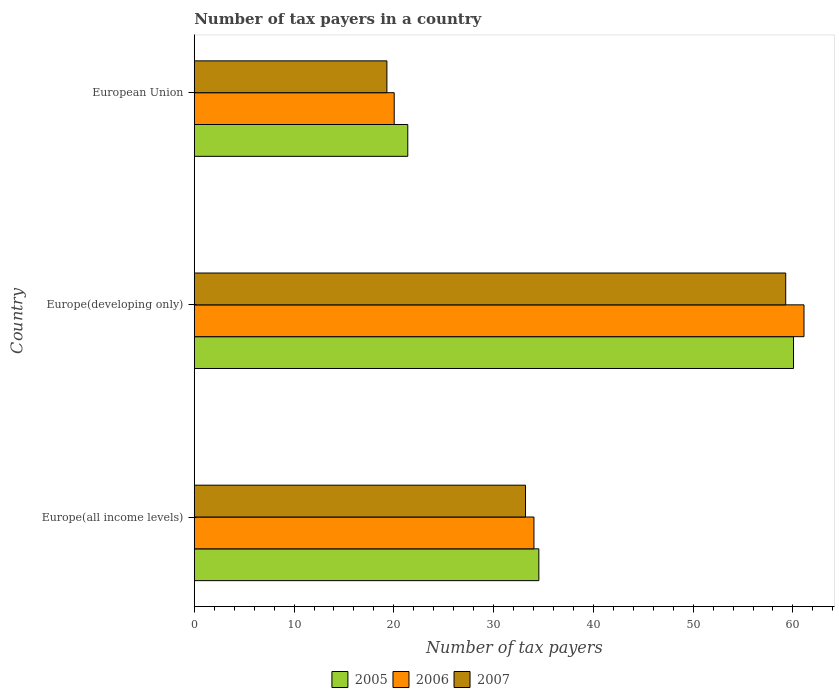How many groups of bars are there?
Ensure brevity in your answer.  3. Are the number of bars on each tick of the Y-axis equal?
Your response must be concise. Yes. What is the label of the 1st group of bars from the top?
Offer a very short reply. European Union. What is the number of tax payers in in 2006 in Europe(developing only)?
Your answer should be very brief. 61.11. Across all countries, what is the maximum number of tax payers in in 2005?
Your response must be concise. 60.06. Across all countries, what is the minimum number of tax payers in in 2005?
Your answer should be compact. 21.4. In which country was the number of tax payers in in 2005 maximum?
Offer a terse response. Europe(developing only). In which country was the number of tax payers in in 2007 minimum?
Provide a short and direct response. European Union. What is the total number of tax payers in in 2006 in the graph?
Provide a succinct answer. 115.19. What is the difference between the number of tax payers in in 2006 in Europe(all income levels) and that in European Union?
Your answer should be very brief. 14.01. What is the difference between the number of tax payers in in 2005 in Europe(developing only) and the number of tax payers in in 2006 in European Union?
Your response must be concise. 40.02. What is the average number of tax payers in in 2005 per country?
Your response must be concise. 38.66. What is the difference between the number of tax payers in in 2006 and number of tax payers in in 2007 in Europe(all income levels)?
Your answer should be compact. 0.84. In how many countries, is the number of tax payers in in 2005 greater than 8 ?
Provide a short and direct response. 3. What is the ratio of the number of tax payers in in 2006 in Europe(all income levels) to that in European Union?
Give a very brief answer. 1.7. Is the number of tax payers in in 2007 in Europe(all income levels) less than that in European Union?
Give a very brief answer. No. What is the difference between the highest and the second highest number of tax payers in in 2007?
Provide a succinct answer. 26.08. What is the difference between the highest and the lowest number of tax payers in in 2006?
Provide a short and direct response. 41.07. In how many countries, is the number of tax payers in in 2007 greater than the average number of tax payers in in 2007 taken over all countries?
Give a very brief answer. 1. Is the sum of the number of tax payers in in 2007 in Europe(all income levels) and European Union greater than the maximum number of tax payers in in 2006 across all countries?
Offer a very short reply. No. What does the 3rd bar from the bottom in European Union represents?
Ensure brevity in your answer.  2007. Is it the case that in every country, the sum of the number of tax payers in in 2007 and number of tax payers in in 2005 is greater than the number of tax payers in in 2006?
Offer a terse response. Yes. How many bars are there?
Provide a succinct answer. 9. Are all the bars in the graph horizontal?
Keep it short and to the point. Yes. What is the difference between two consecutive major ticks on the X-axis?
Your answer should be compact. 10. Does the graph contain any zero values?
Your answer should be compact. No. Does the graph contain grids?
Offer a very short reply. No. Where does the legend appear in the graph?
Ensure brevity in your answer.  Bottom center. How many legend labels are there?
Make the answer very short. 3. How are the legend labels stacked?
Ensure brevity in your answer.  Horizontal. What is the title of the graph?
Offer a very short reply. Number of tax payers in a country. Does "1984" appear as one of the legend labels in the graph?
Your answer should be compact. No. What is the label or title of the X-axis?
Your answer should be very brief. Number of tax payers. What is the label or title of the Y-axis?
Your response must be concise. Country. What is the Number of tax payers in 2005 in Europe(all income levels)?
Give a very brief answer. 34.53. What is the Number of tax payers of 2006 in Europe(all income levels)?
Give a very brief answer. 34.04. What is the Number of tax payers of 2007 in Europe(all income levels)?
Your answer should be very brief. 33.2. What is the Number of tax payers of 2005 in Europe(developing only)?
Give a very brief answer. 60.06. What is the Number of tax payers in 2006 in Europe(developing only)?
Provide a succinct answer. 61.11. What is the Number of tax payers in 2007 in Europe(developing only)?
Provide a short and direct response. 59.28. What is the Number of tax payers in 2005 in European Union?
Make the answer very short. 21.4. What is the Number of tax payers of 2006 in European Union?
Give a very brief answer. 20.04. What is the Number of tax payers in 2007 in European Union?
Make the answer very short. 19.31. Across all countries, what is the maximum Number of tax payers in 2005?
Provide a short and direct response. 60.06. Across all countries, what is the maximum Number of tax payers in 2006?
Ensure brevity in your answer.  61.11. Across all countries, what is the maximum Number of tax payers of 2007?
Keep it short and to the point. 59.28. Across all countries, what is the minimum Number of tax payers of 2005?
Your response must be concise. 21.4. Across all countries, what is the minimum Number of tax payers in 2006?
Make the answer very short. 20.04. Across all countries, what is the minimum Number of tax payers of 2007?
Provide a succinct answer. 19.31. What is the total Number of tax payers of 2005 in the graph?
Make the answer very short. 115.99. What is the total Number of tax payers in 2006 in the graph?
Your answer should be very brief. 115.19. What is the total Number of tax payers of 2007 in the graph?
Provide a succinct answer. 111.79. What is the difference between the Number of tax payers of 2005 in Europe(all income levels) and that in Europe(developing only)?
Your response must be concise. -25.52. What is the difference between the Number of tax payers in 2006 in Europe(all income levels) and that in Europe(developing only)?
Offer a very short reply. -27.07. What is the difference between the Number of tax payers in 2007 in Europe(all income levels) and that in Europe(developing only)?
Keep it short and to the point. -26.08. What is the difference between the Number of tax payers in 2005 in Europe(all income levels) and that in European Union?
Your response must be concise. 13.13. What is the difference between the Number of tax payers of 2006 in Europe(all income levels) and that in European Union?
Provide a short and direct response. 14.01. What is the difference between the Number of tax payers in 2007 in Europe(all income levels) and that in European Union?
Your response must be concise. 13.89. What is the difference between the Number of tax payers of 2005 in Europe(developing only) and that in European Union?
Provide a succinct answer. 38.66. What is the difference between the Number of tax payers of 2006 in Europe(developing only) and that in European Union?
Offer a terse response. 41.07. What is the difference between the Number of tax payers in 2007 in Europe(developing only) and that in European Union?
Your response must be concise. 39.97. What is the difference between the Number of tax payers of 2005 in Europe(all income levels) and the Number of tax payers of 2006 in Europe(developing only)?
Your answer should be compact. -26.58. What is the difference between the Number of tax payers of 2005 in Europe(all income levels) and the Number of tax payers of 2007 in Europe(developing only)?
Keep it short and to the point. -24.74. What is the difference between the Number of tax payers in 2006 in Europe(all income levels) and the Number of tax payers in 2007 in Europe(developing only)?
Ensure brevity in your answer.  -25.23. What is the difference between the Number of tax payers in 2005 in Europe(all income levels) and the Number of tax payers in 2006 in European Union?
Provide a short and direct response. 14.5. What is the difference between the Number of tax payers of 2005 in Europe(all income levels) and the Number of tax payers of 2007 in European Union?
Provide a short and direct response. 15.23. What is the difference between the Number of tax payers of 2006 in Europe(all income levels) and the Number of tax payers of 2007 in European Union?
Your answer should be very brief. 14.74. What is the difference between the Number of tax payers in 2005 in Europe(developing only) and the Number of tax payers in 2006 in European Union?
Offer a very short reply. 40.02. What is the difference between the Number of tax payers in 2005 in Europe(developing only) and the Number of tax payers in 2007 in European Union?
Offer a very short reply. 40.75. What is the difference between the Number of tax payers of 2006 in Europe(developing only) and the Number of tax payers of 2007 in European Union?
Provide a short and direct response. 41.8. What is the average Number of tax payers of 2005 per country?
Provide a short and direct response. 38.66. What is the average Number of tax payers of 2006 per country?
Keep it short and to the point. 38.4. What is the average Number of tax payers of 2007 per country?
Give a very brief answer. 37.26. What is the difference between the Number of tax payers of 2005 and Number of tax payers of 2006 in Europe(all income levels)?
Ensure brevity in your answer.  0.49. What is the difference between the Number of tax payers in 2005 and Number of tax payers in 2007 in Europe(all income levels)?
Your response must be concise. 1.33. What is the difference between the Number of tax payers of 2006 and Number of tax payers of 2007 in Europe(all income levels)?
Offer a very short reply. 0.84. What is the difference between the Number of tax payers in 2005 and Number of tax payers in 2006 in Europe(developing only)?
Make the answer very short. -1.05. What is the difference between the Number of tax payers of 2005 and Number of tax payers of 2007 in Europe(developing only)?
Your response must be concise. 0.78. What is the difference between the Number of tax payers in 2006 and Number of tax payers in 2007 in Europe(developing only)?
Provide a succinct answer. 1.83. What is the difference between the Number of tax payers of 2005 and Number of tax payers of 2006 in European Union?
Offer a very short reply. 1.36. What is the difference between the Number of tax payers of 2005 and Number of tax payers of 2007 in European Union?
Your answer should be compact. 2.09. What is the difference between the Number of tax payers of 2006 and Number of tax payers of 2007 in European Union?
Give a very brief answer. 0.73. What is the ratio of the Number of tax payers of 2005 in Europe(all income levels) to that in Europe(developing only)?
Make the answer very short. 0.57. What is the ratio of the Number of tax payers of 2006 in Europe(all income levels) to that in Europe(developing only)?
Give a very brief answer. 0.56. What is the ratio of the Number of tax payers in 2007 in Europe(all income levels) to that in Europe(developing only)?
Offer a terse response. 0.56. What is the ratio of the Number of tax payers of 2005 in Europe(all income levels) to that in European Union?
Offer a very short reply. 1.61. What is the ratio of the Number of tax payers of 2006 in Europe(all income levels) to that in European Union?
Provide a short and direct response. 1.7. What is the ratio of the Number of tax payers of 2007 in Europe(all income levels) to that in European Union?
Your response must be concise. 1.72. What is the ratio of the Number of tax payers in 2005 in Europe(developing only) to that in European Union?
Provide a short and direct response. 2.81. What is the ratio of the Number of tax payers in 2006 in Europe(developing only) to that in European Union?
Give a very brief answer. 3.05. What is the ratio of the Number of tax payers in 2007 in Europe(developing only) to that in European Union?
Make the answer very short. 3.07. What is the difference between the highest and the second highest Number of tax payers of 2005?
Give a very brief answer. 25.52. What is the difference between the highest and the second highest Number of tax payers in 2006?
Ensure brevity in your answer.  27.07. What is the difference between the highest and the second highest Number of tax payers of 2007?
Keep it short and to the point. 26.08. What is the difference between the highest and the lowest Number of tax payers of 2005?
Your answer should be very brief. 38.66. What is the difference between the highest and the lowest Number of tax payers of 2006?
Keep it short and to the point. 41.07. What is the difference between the highest and the lowest Number of tax payers in 2007?
Provide a short and direct response. 39.97. 